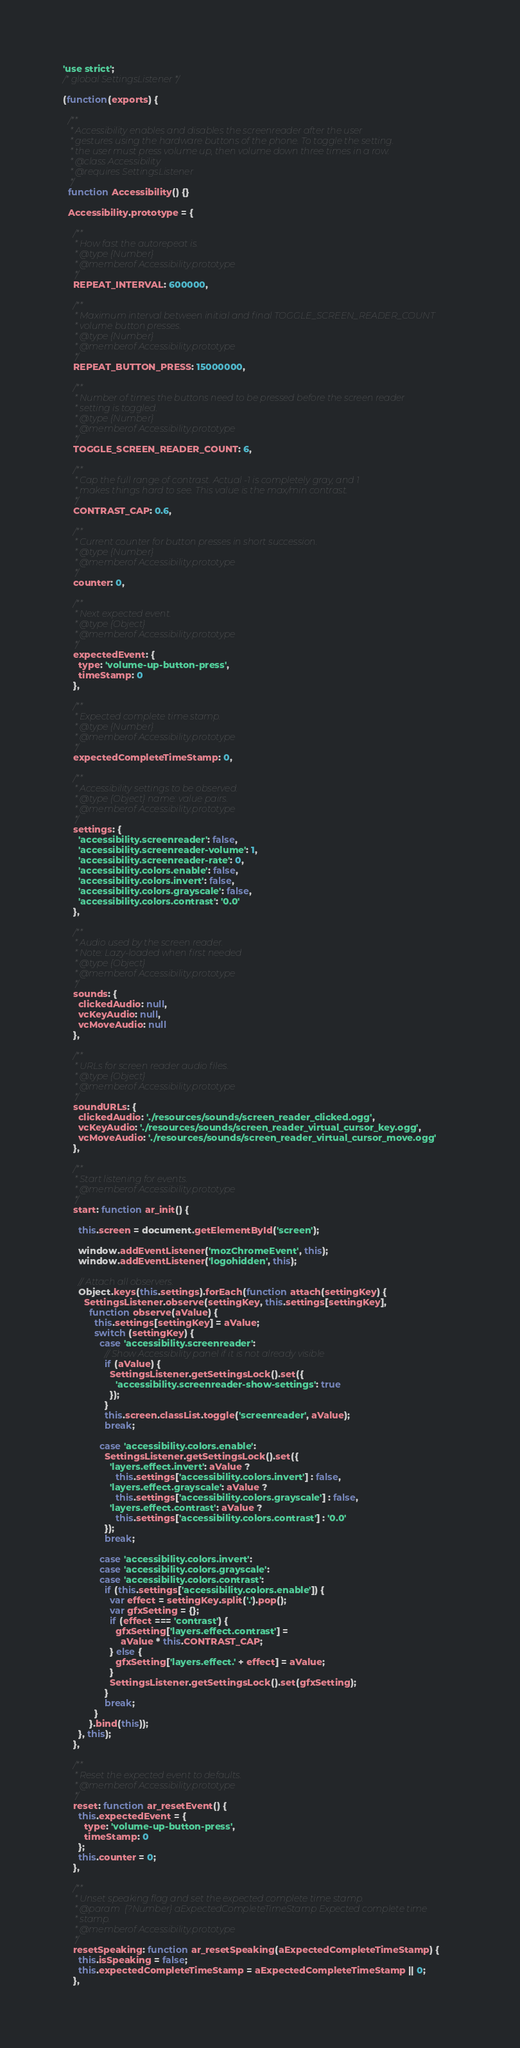Convert code to text. <code><loc_0><loc_0><loc_500><loc_500><_JavaScript_>'use strict';
/* global SettingsListener */

(function(exports) {

  /**
   * Accessibility enables and disables the screenreader after the user
   * gestures using the hardware buttons of the phone. To toggle the setting.
   * the user must press volume up, then volume down three times in a row.
   * @class Accessibility
   * @requires SettingsListener
   */
  function Accessibility() {}

  Accessibility.prototype = {

    /**
     * How fast the autorepeat is.
     * @type {Number}
     * @memberof Accessibility.prototype
     */
    REPEAT_INTERVAL: 600000,

    /**
     * Maximum interval between initial and final TOGGLE_SCREEN_READER_COUNT
     * volume button presses.
     * @type {Number}
     * @memberof Accessibility.prototype
     */
    REPEAT_BUTTON_PRESS: 15000000,

    /**
     * Number of times the buttons need to be pressed before the screen reader
     * setting is toggled.
     * @type {Number}
     * @memberof Accessibility.prototype
     */
    TOGGLE_SCREEN_READER_COUNT: 6,

    /**
     * Cap the full range of contrast. Actual -1 is completely gray, and 1
     * makes things hard to see. This value is the max/min contrast.
     */
    CONTRAST_CAP: 0.6,

    /**
     * Current counter for button presses in short succession.
     * @type {Number}
     * @memberof Accessibility.prototype
     */
    counter: 0,

    /**
     * Next expected event.
     * @type {Object}
     * @memberof Accessibility.prototype
     */
    expectedEvent: {
      type: 'volume-up-button-press',
      timeStamp: 0
    },

    /**
     * Expected complete time stamp.
     * @type {Number}
     * @memberof Accessibility.prototype
     */
    expectedCompleteTimeStamp: 0,

    /**
     * Accessibility settings to be observed.
     * @type {Object} name: value pairs.
     * @memberof Accessibility.prototype
     */
    settings: {
      'accessibility.screenreader': false,
      'accessibility.screenreader-volume': 1,
      'accessibility.screenreader-rate': 0,
      'accessibility.colors.enable': false,
      'accessibility.colors.invert': false,
      'accessibility.colors.grayscale': false,
      'accessibility.colors.contrast': '0.0'
    },

    /**
     * Audio used by the screen reader.
     * Note: Lazy-loaded when first needed
     * @type {Object}
     * @memberof Accessibility.prototype
     */
    sounds: {
      clickedAudio: null,
      vcKeyAudio: null,
      vcMoveAudio: null
    },

    /**
     * URLs for screen reader audio files.
     * @type {Object}
     * @memberof Accessibility.prototype
     */
    soundURLs: {
      clickedAudio: './resources/sounds/screen_reader_clicked.ogg',
      vcKeyAudio: './resources/sounds/screen_reader_virtual_cursor_key.ogg',
      vcMoveAudio: './resources/sounds/screen_reader_virtual_cursor_move.ogg'
    },

    /**
     * Start listening for events.
     * @memberof Accessibility.prototype
     */
    start: function ar_init() {

      this.screen = document.getElementById('screen');

      window.addEventListener('mozChromeEvent', this);
      window.addEventListener('logohidden', this);

      // Attach all observers.
      Object.keys(this.settings).forEach(function attach(settingKey) {
        SettingsListener.observe(settingKey, this.settings[settingKey],
          function observe(aValue) {
            this.settings[settingKey] = aValue;
            switch (settingKey) {
              case 'accessibility.screenreader':
                // Show Accessibility panel if it is not already visible
                if (aValue) {
                  SettingsListener.getSettingsLock().set({
                    'accessibility.screenreader-show-settings': true
                  });
                }
                this.screen.classList.toggle('screenreader', aValue);
                break;

              case 'accessibility.colors.enable':
                SettingsListener.getSettingsLock().set({
                  'layers.effect.invert': aValue ?
                    this.settings['accessibility.colors.invert'] : false,
                  'layers.effect.grayscale': aValue ?
                    this.settings['accessibility.colors.grayscale'] : false,
                  'layers.effect.contrast': aValue ?
                    this.settings['accessibility.colors.contrast'] : '0.0'
                });
                break;

              case 'accessibility.colors.invert':
              case 'accessibility.colors.grayscale':
              case 'accessibility.colors.contrast':
                if (this.settings['accessibility.colors.enable']) {
                  var effect = settingKey.split('.').pop();
                  var gfxSetting = {};
                  if (effect === 'contrast') {
                    gfxSetting['layers.effect.contrast'] =
                      aValue * this.CONTRAST_CAP;
                  } else {
                    gfxSetting['layers.effect.' + effect] = aValue;
                  }
                  SettingsListener.getSettingsLock().set(gfxSetting);
                }
                break;
            }
          }.bind(this));
      }, this);
    },

    /**
     * Reset the expected event to defaults.
     * @memberof Accessibility.prototype
     */
    reset: function ar_resetEvent() {
      this.expectedEvent = {
        type: 'volume-up-button-press',
        timeStamp: 0
      };
      this.counter = 0;
    },

    /**
     * Unset speaking flag and set the expected complete time stamp.
     * @param  {?Number} aExpectedCompleteTimeStamp Expected complete time
     * stamp.
     * @memberof Accessibility.prototype
     */
    resetSpeaking: function ar_resetSpeaking(aExpectedCompleteTimeStamp) {
      this.isSpeaking = false;
      this.expectedCompleteTimeStamp = aExpectedCompleteTimeStamp || 0;
    },
</code> 